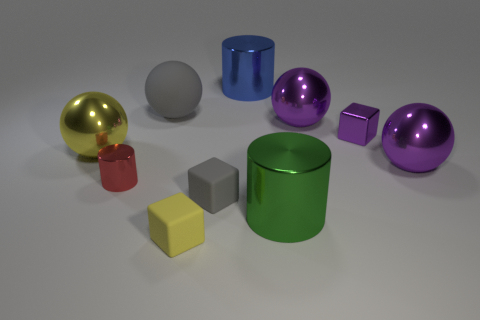There is a matte object that is the same color as the matte sphere; what shape is it?
Provide a succinct answer. Cube. Is there a small object that has the same color as the big matte object?
Provide a succinct answer. Yes. What is the big gray ball made of?
Ensure brevity in your answer.  Rubber. What number of purple metal objects are there?
Offer a terse response. 3. Does the block that is behind the small red metallic cylinder have the same color as the shiny thing that is right of the purple block?
Keep it short and to the point. Yes. How many other objects are the same size as the red metallic thing?
Make the answer very short. 3. What is the color of the large shiny ball that is on the left side of the small red cylinder?
Give a very brief answer. Yellow. Is the gray object left of the small yellow block made of the same material as the small gray thing?
Offer a very short reply. Yes. What number of things are in front of the yellow metal object and on the left side of the small yellow block?
Provide a succinct answer. 1. What color is the metal ball to the left of the big purple metal sphere to the left of the thing right of the tiny purple thing?
Ensure brevity in your answer.  Yellow. 